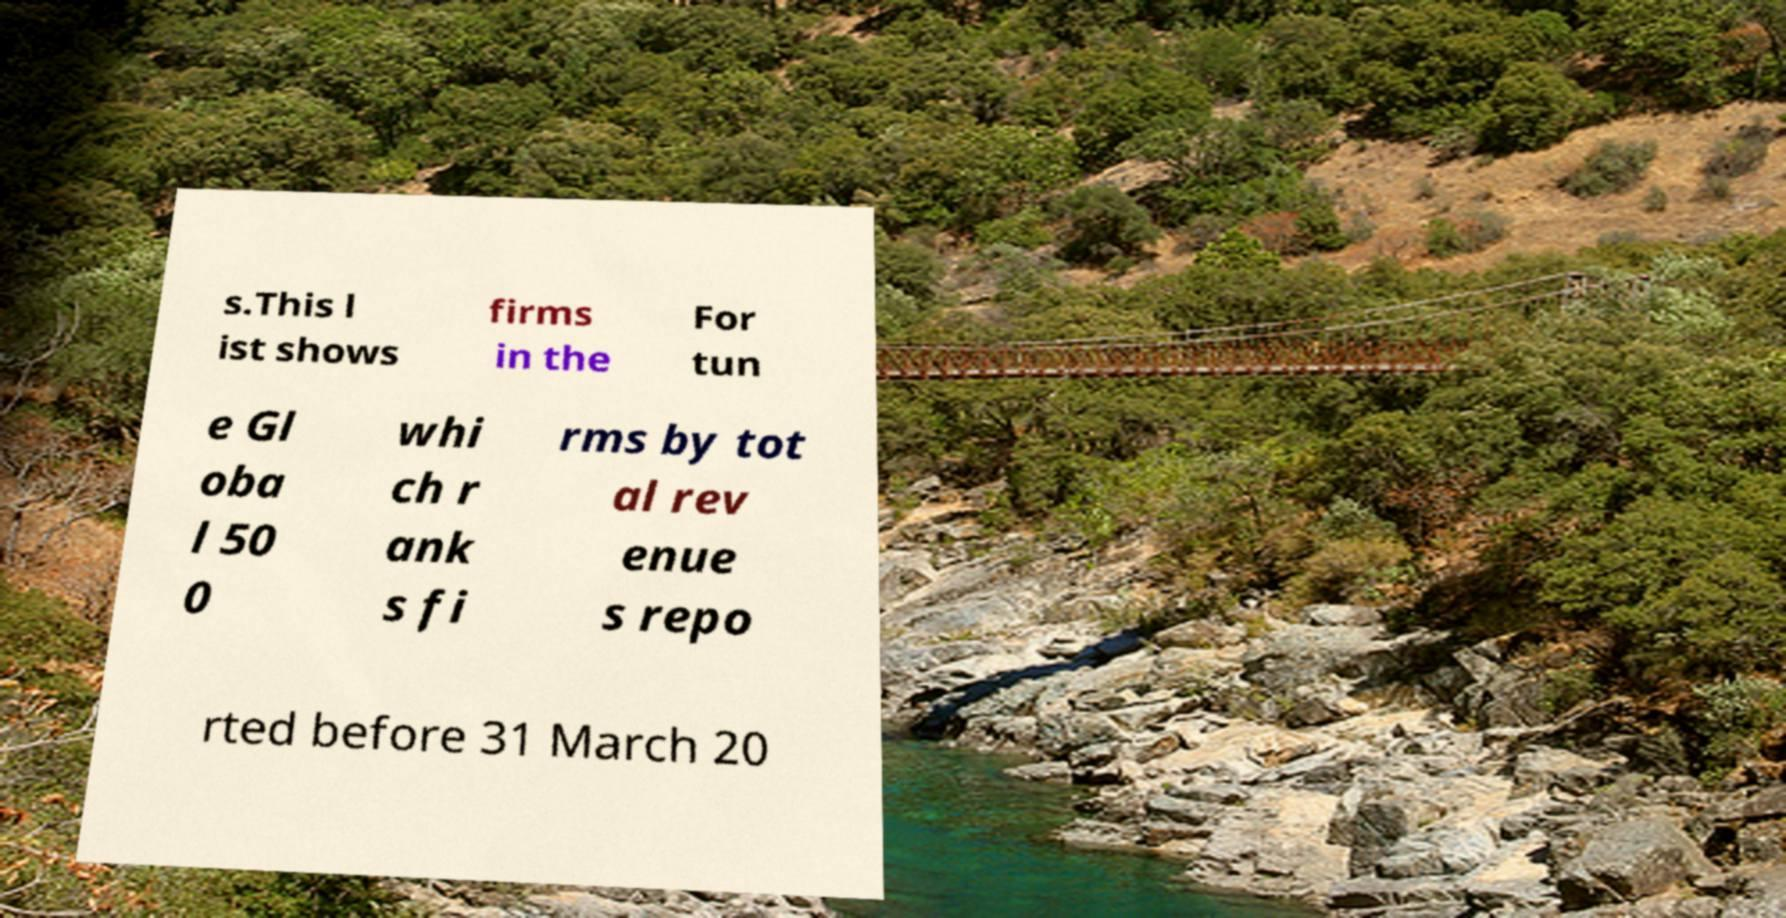Can you accurately transcribe the text from the provided image for me? s.This l ist shows firms in the For tun e Gl oba l 50 0 whi ch r ank s fi rms by tot al rev enue s repo rted before 31 March 20 